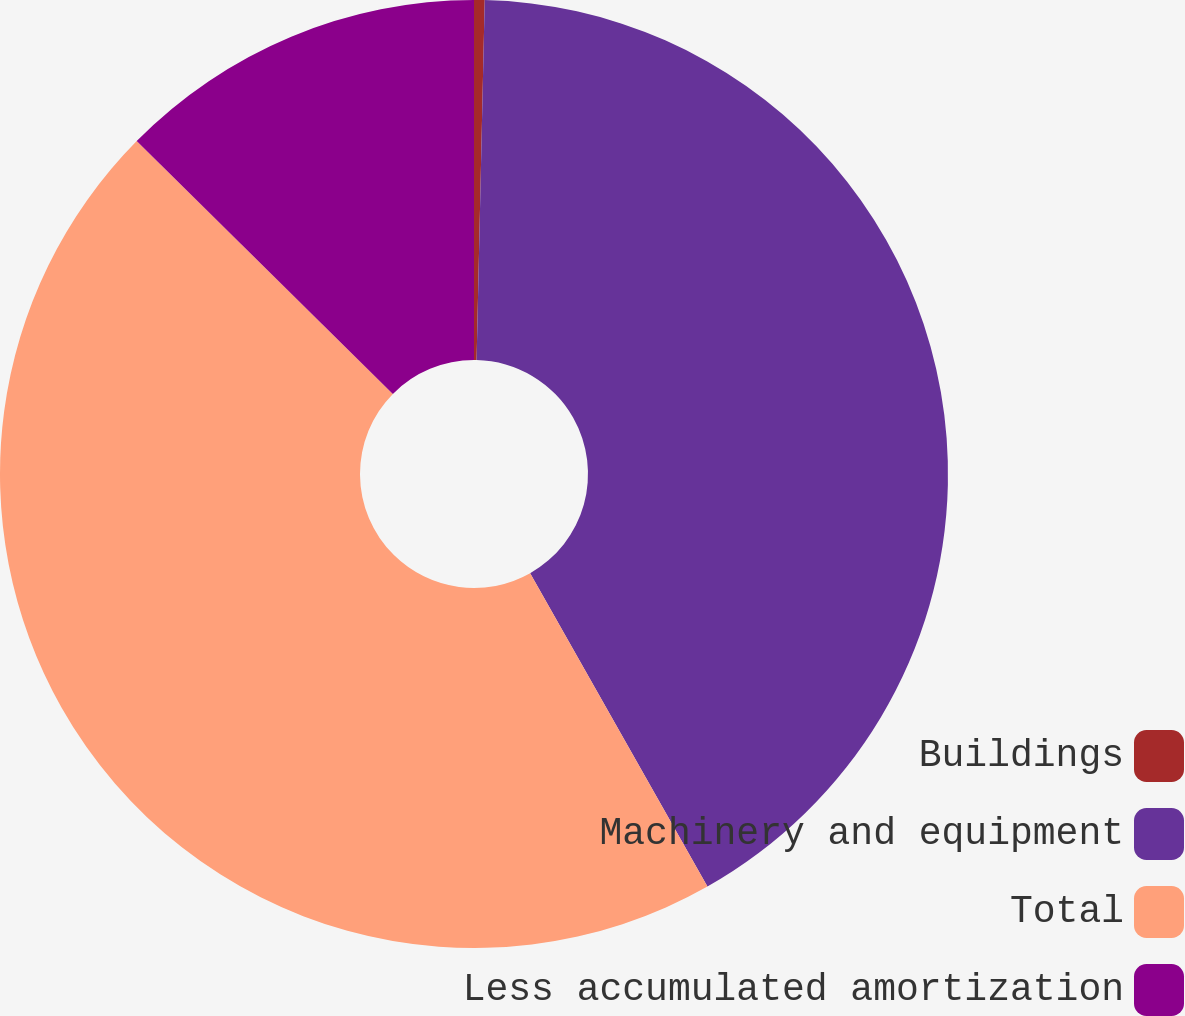Convert chart to OTSL. <chart><loc_0><loc_0><loc_500><loc_500><pie_chart><fcel>Buildings<fcel>Machinery and equipment<fcel>Total<fcel>Less accumulated amortization<nl><fcel>0.36%<fcel>41.44%<fcel>45.59%<fcel>12.6%<nl></chart> 